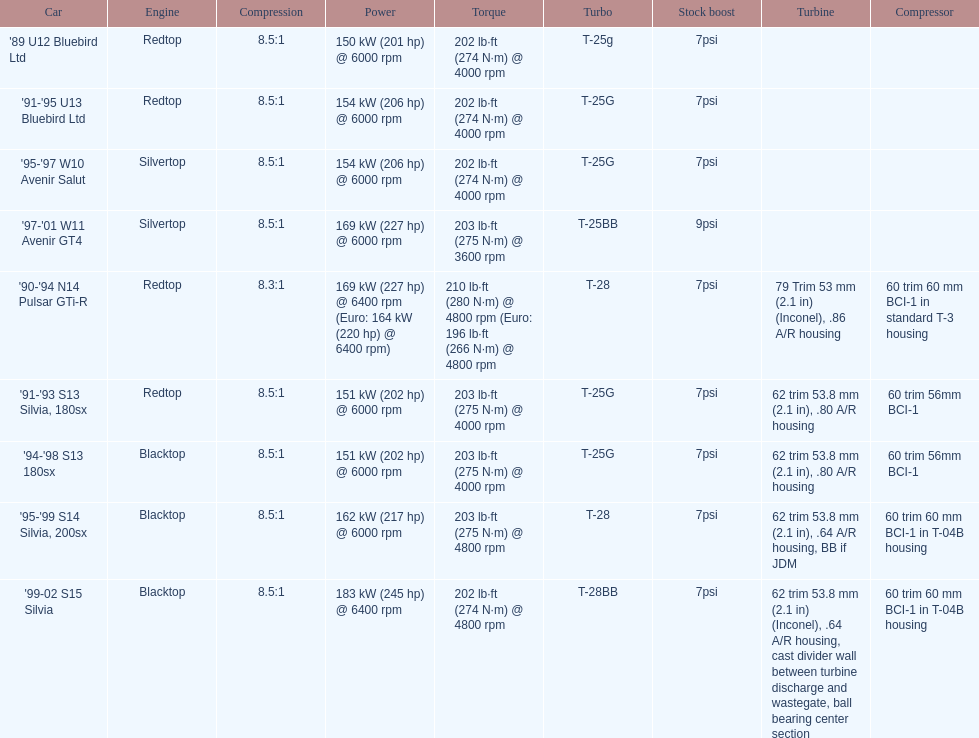Which engines are the same as the first entry ('89 u12 bluebird ltd)? '91-'95 U13 Bluebird Ltd, '90-'94 N14 Pulsar GTi-R, '91-'93 S13 Silvia, 180sx. 